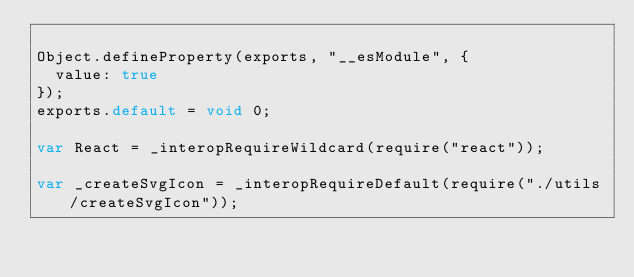<code> <loc_0><loc_0><loc_500><loc_500><_JavaScript_>
Object.defineProperty(exports, "__esModule", {
  value: true
});
exports.default = void 0;

var React = _interopRequireWildcard(require("react"));

var _createSvgIcon = _interopRequireDefault(require("./utils/createSvgIcon"));
</code> 